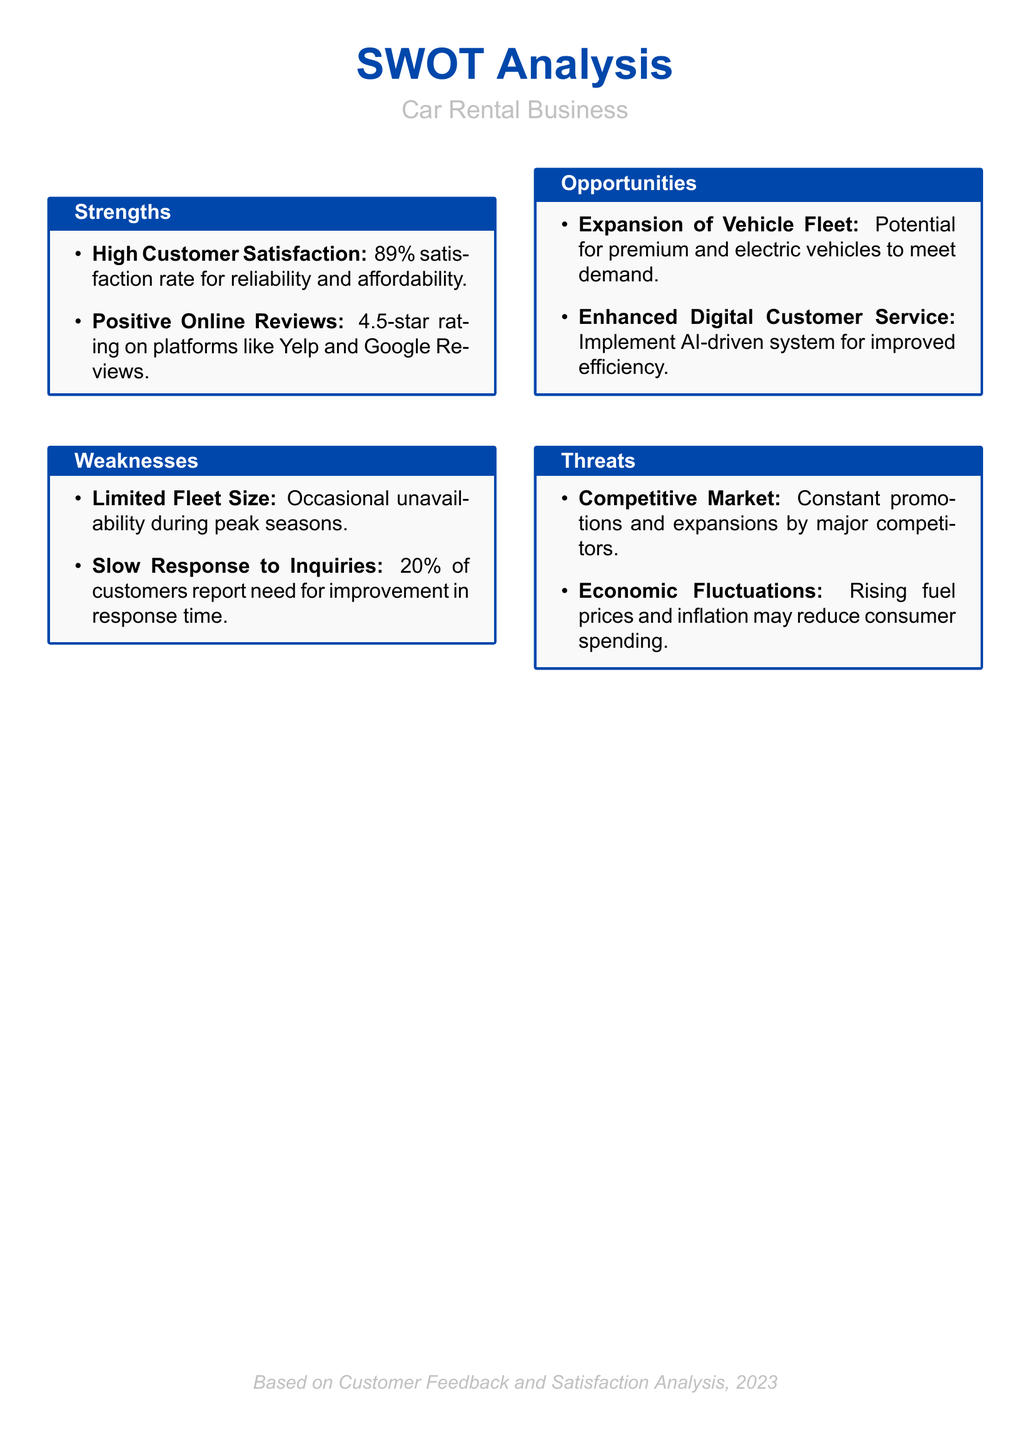What is the customer satisfaction rate? The satisfaction rate indicates the percentage of customers who are satisfied with the services, which is stated as 89%.
Answer: 89% What is the average rating on online platforms? The average rating across platforms like Yelp and Google Reviews reflects customer feedback, specifically noted as a 4.5-star rating.
Answer: 4.5-star What percentage of customers reported slow response to inquiries? This percentage represents customers' feedback regarding the need for improvement in response time, which is noted as 20%.
Answer: 20% What opportunities are mentioned for fleet expansion? This opportunity signifies the potential for diversifying the vehicle offerings based on market demand, highlighted as premium and electric vehicles.
Answer: Premium and electric vehicles What is identified as a threat from competitors? This threat encompasses the constant competition in the market, specifically the promotions and expansions executed by larger competitors.
Answer: Constant promotions and expansions 